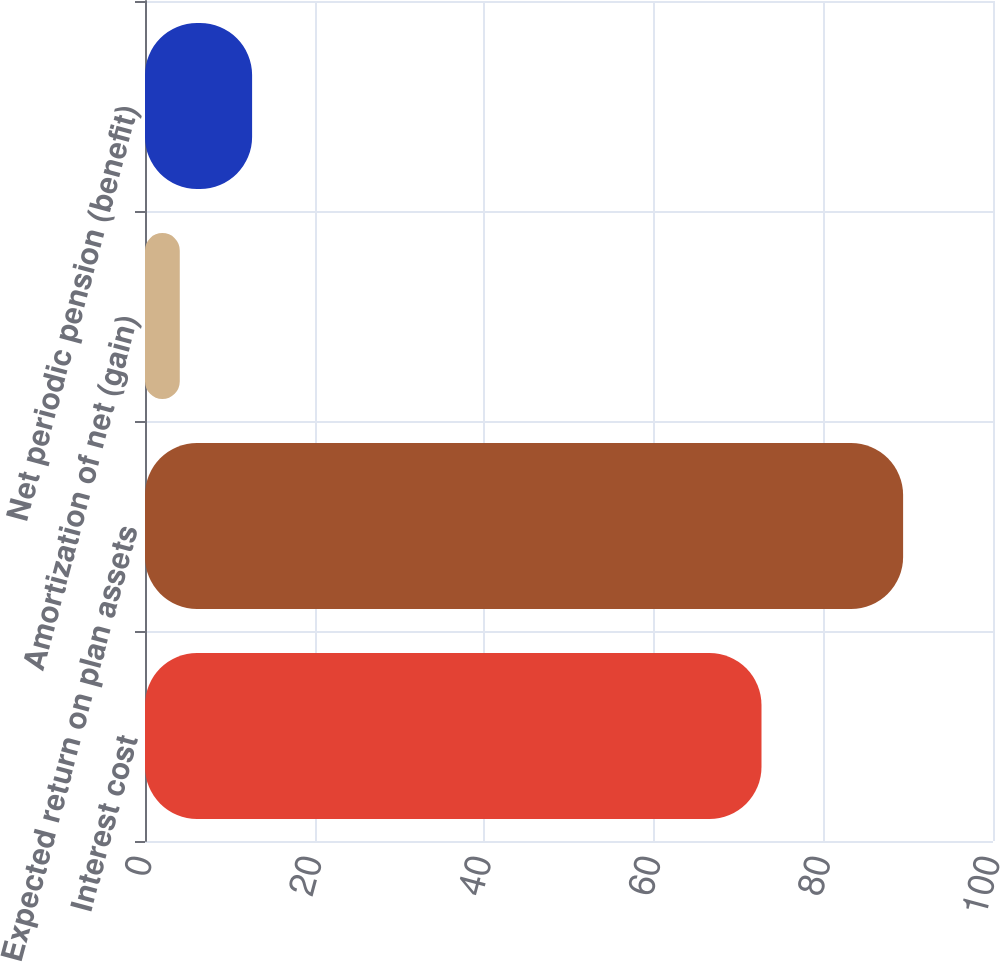<chart> <loc_0><loc_0><loc_500><loc_500><bar_chart><fcel>Interest cost<fcel>Expected return on plan assets<fcel>Amortization of net (gain)<fcel>Net periodic pension (benefit)<nl><fcel>72.7<fcel>89.4<fcel>4.1<fcel>12.63<nl></chart> 